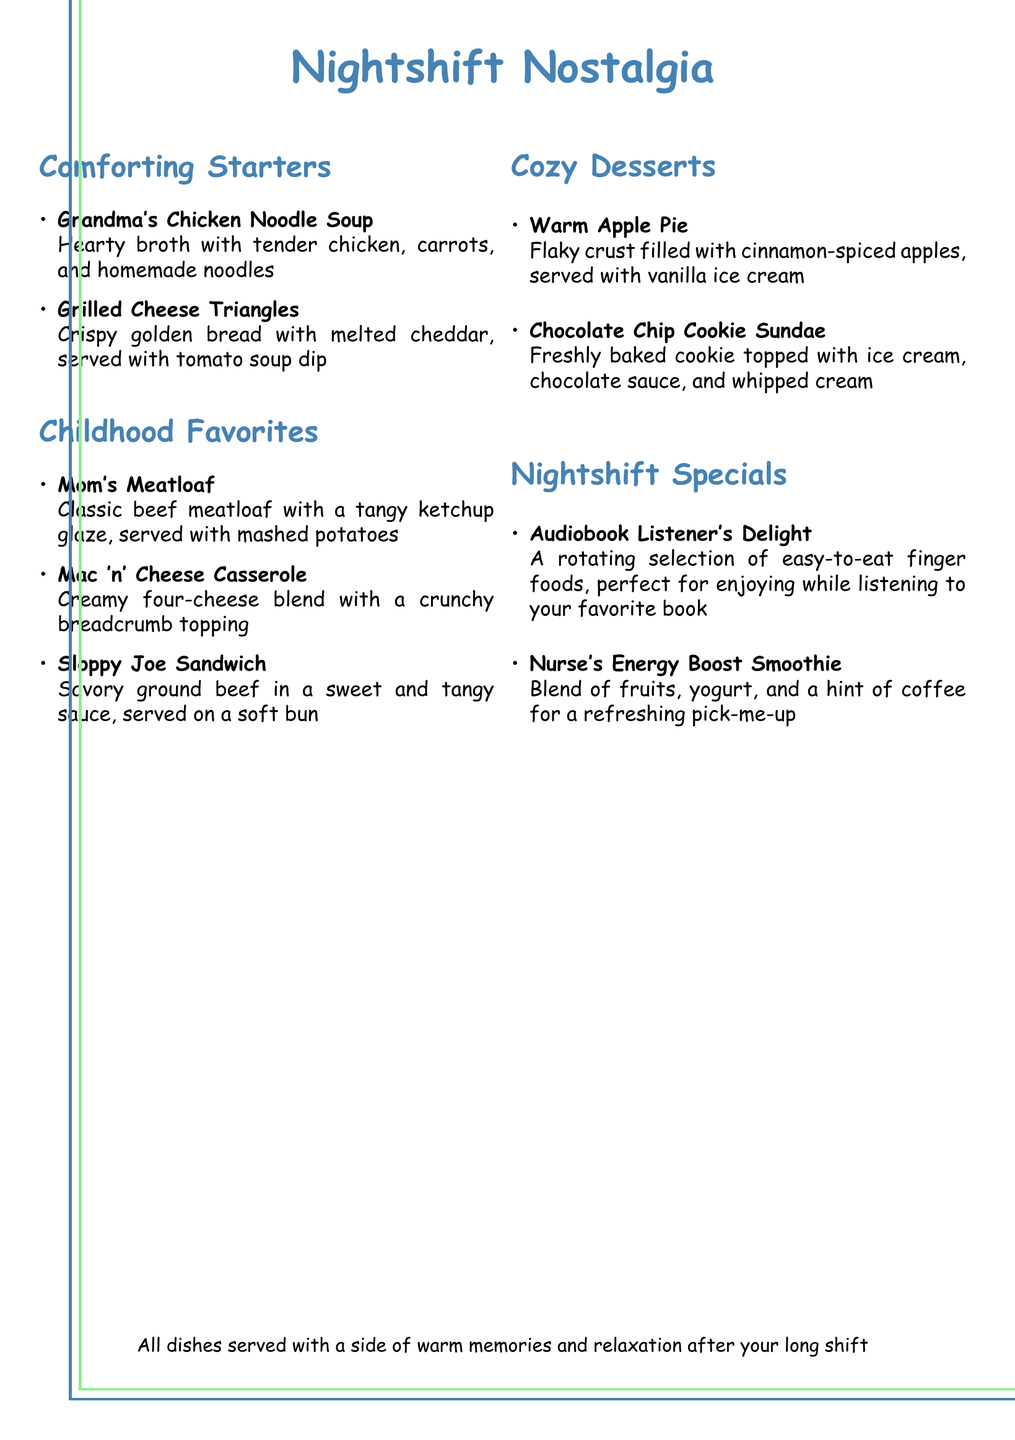What is the title of the menu? The title is prominently displayed at the top of the document.
Answer: Nightshift Nostalgia How many sections are there in the menu? The menu is divided into four sections: Comforting Starters, Childhood Favorites, Cozy Desserts, and Nightshift Specials.
Answer: Four What dish is served with tomato soup dip? The document lists specific dishes along with their descriptions, mentioning a side for one of them.
Answer: Grilled Cheese Triangles Which dessert features vanilla ice cream? The descriptions of desserts specify the accompaniments of each item.
Answer: Warm Apple Pie What type of dish is "Mom's Meatloaf"? The menu categorizes it under Childhood Favorites, indicating its type.
Answer: Childhood Favorite What is served with the "Chocolate Chip Cookie Sundae"? The document includes details about toppings for this dessert.
Answer: Ice cream, chocolate sauce, and whipped cream Which menu item is perfect for listening to audiobooks? The document specifically identifies one item as designed for audiobook listeners.
Answer: Audiobook Listener's Delight What color is used for section titles? The document defines a specific color for this purpose, indicating its visual theme.
Answer: Nurseblue What is the main ingredient in the "Nurse's Energy Boost Smoothie"? The smoothie includes a mixture that pertains to its refreshing nature, highlighted in the description.
Answer: Fruits and yogurt 